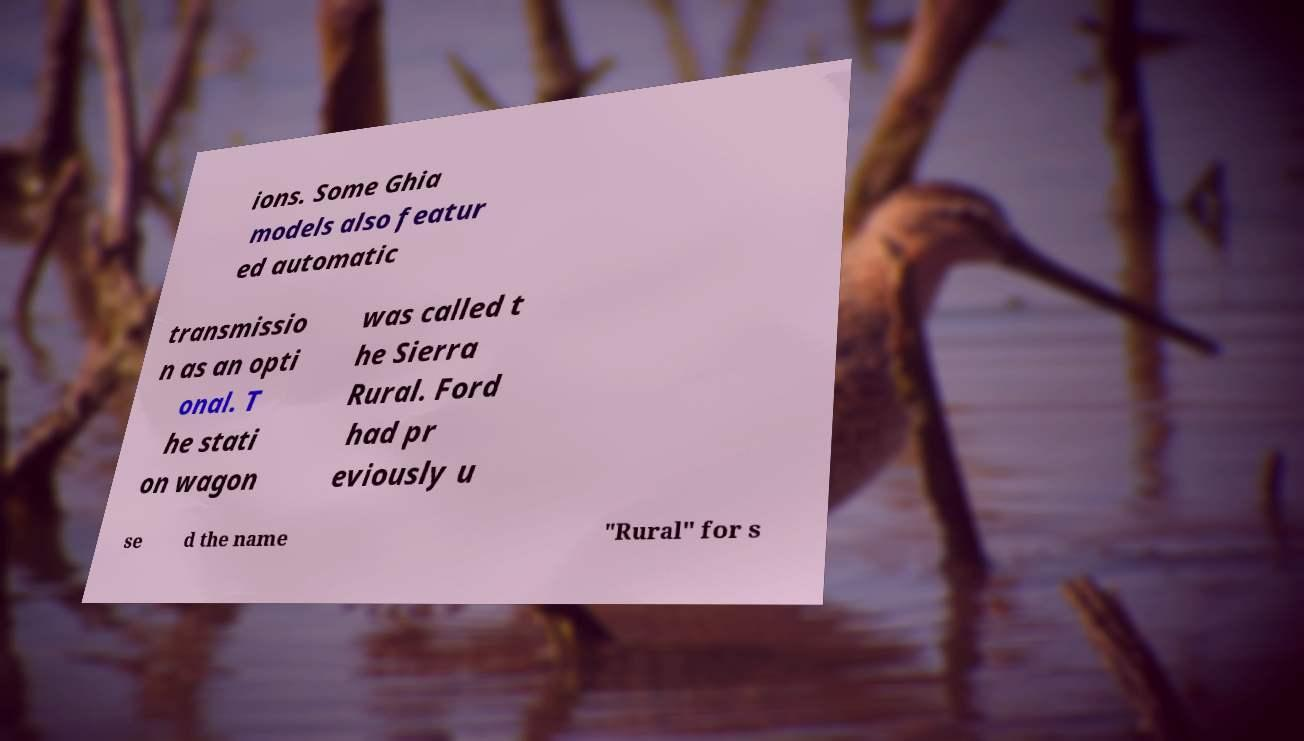Could you assist in decoding the text presented in this image and type it out clearly? ions. Some Ghia models also featur ed automatic transmissio n as an opti onal. T he stati on wagon was called t he Sierra Rural. Ford had pr eviously u se d the name "Rural" for s 